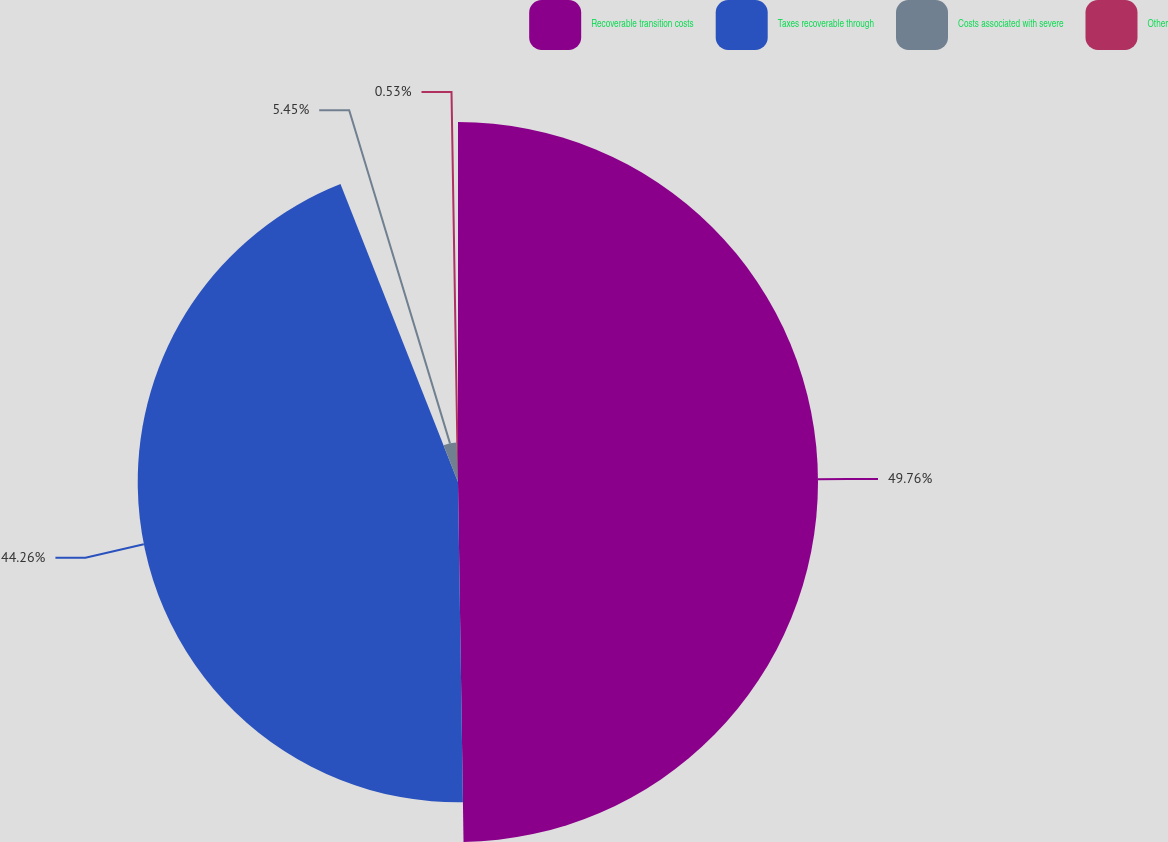Convert chart. <chart><loc_0><loc_0><loc_500><loc_500><pie_chart><fcel>Recoverable transition costs<fcel>Taxes recoverable through<fcel>Costs associated with severe<fcel>Other<nl><fcel>49.75%<fcel>44.26%<fcel>5.45%<fcel>0.53%<nl></chart> 